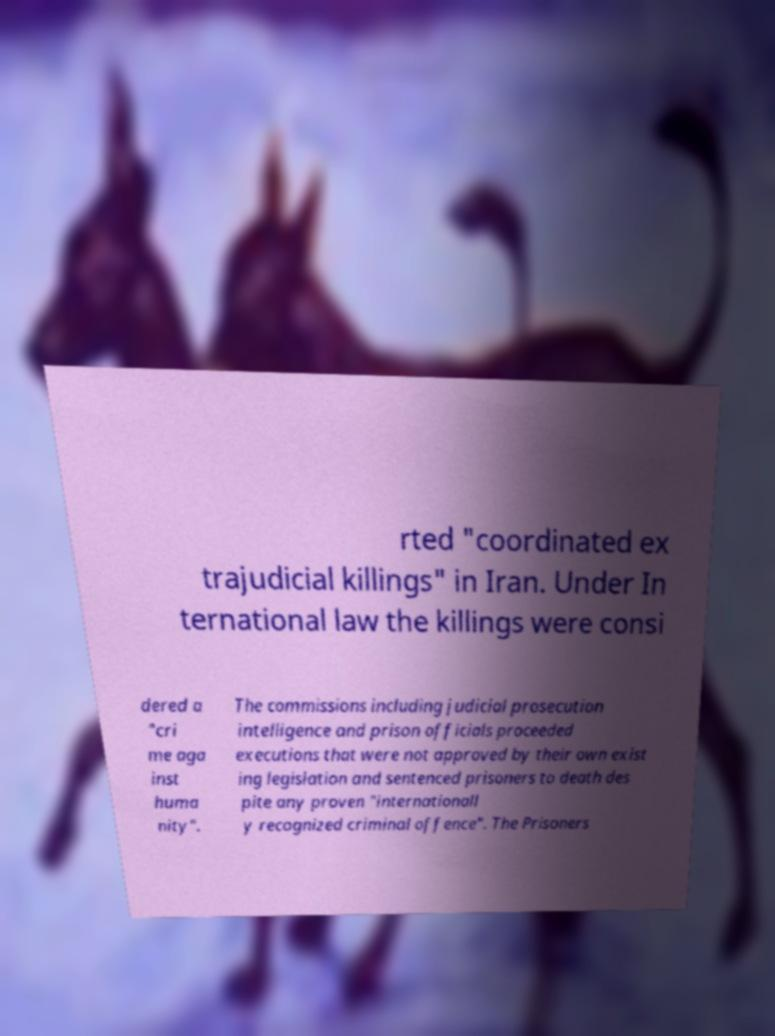Could you extract and type out the text from this image? rted "coordinated ex trajudicial killings" in Iran. Under In ternational law the killings were consi dered a "cri me aga inst huma nity". The commissions including judicial prosecution intelligence and prison officials proceeded executions that were not approved by their own exist ing legislation and sentenced prisoners to death des pite any proven "internationall y recognized criminal offence". The Prisoners 